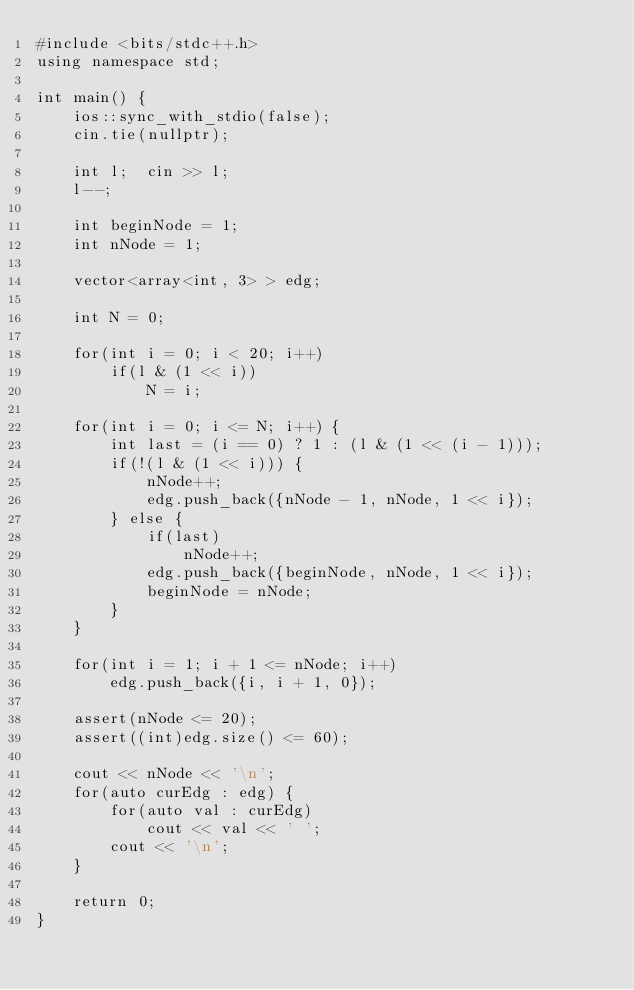Convert code to text. <code><loc_0><loc_0><loc_500><loc_500><_C++_>#include <bits/stdc++.h>
using namespace std;

int main() {
    ios::sync_with_stdio(false);
    cin.tie(nullptr);

    int l;  cin >> l;
    l--;

    int beginNode = 1;
    int nNode = 1;

    vector<array<int, 3> > edg;

    int N = 0;

    for(int i = 0; i < 20; i++)
        if(l & (1 << i))
            N = i;

    for(int i = 0; i <= N; i++) {
        int last = (i == 0) ? 1 : (l & (1 << (i - 1)));
        if(!(l & (1 << i))) {
            nNode++;
            edg.push_back({nNode - 1, nNode, 1 << i});
        } else {
            if(last)
                nNode++;
            edg.push_back({beginNode, nNode, 1 << i});
            beginNode = nNode;
        }
    }

    for(int i = 1; i + 1 <= nNode; i++)
        edg.push_back({i, i + 1, 0});

    assert(nNode <= 20);
    assert((int)edg.size() <= 60);

    cout << nNode << '\n';
    for(auto curEdg : edg) {
        for(auto val : curEdg)
            cout << val << ' ';
        cout << '\n';
    }

    return 0;
}
</code> 